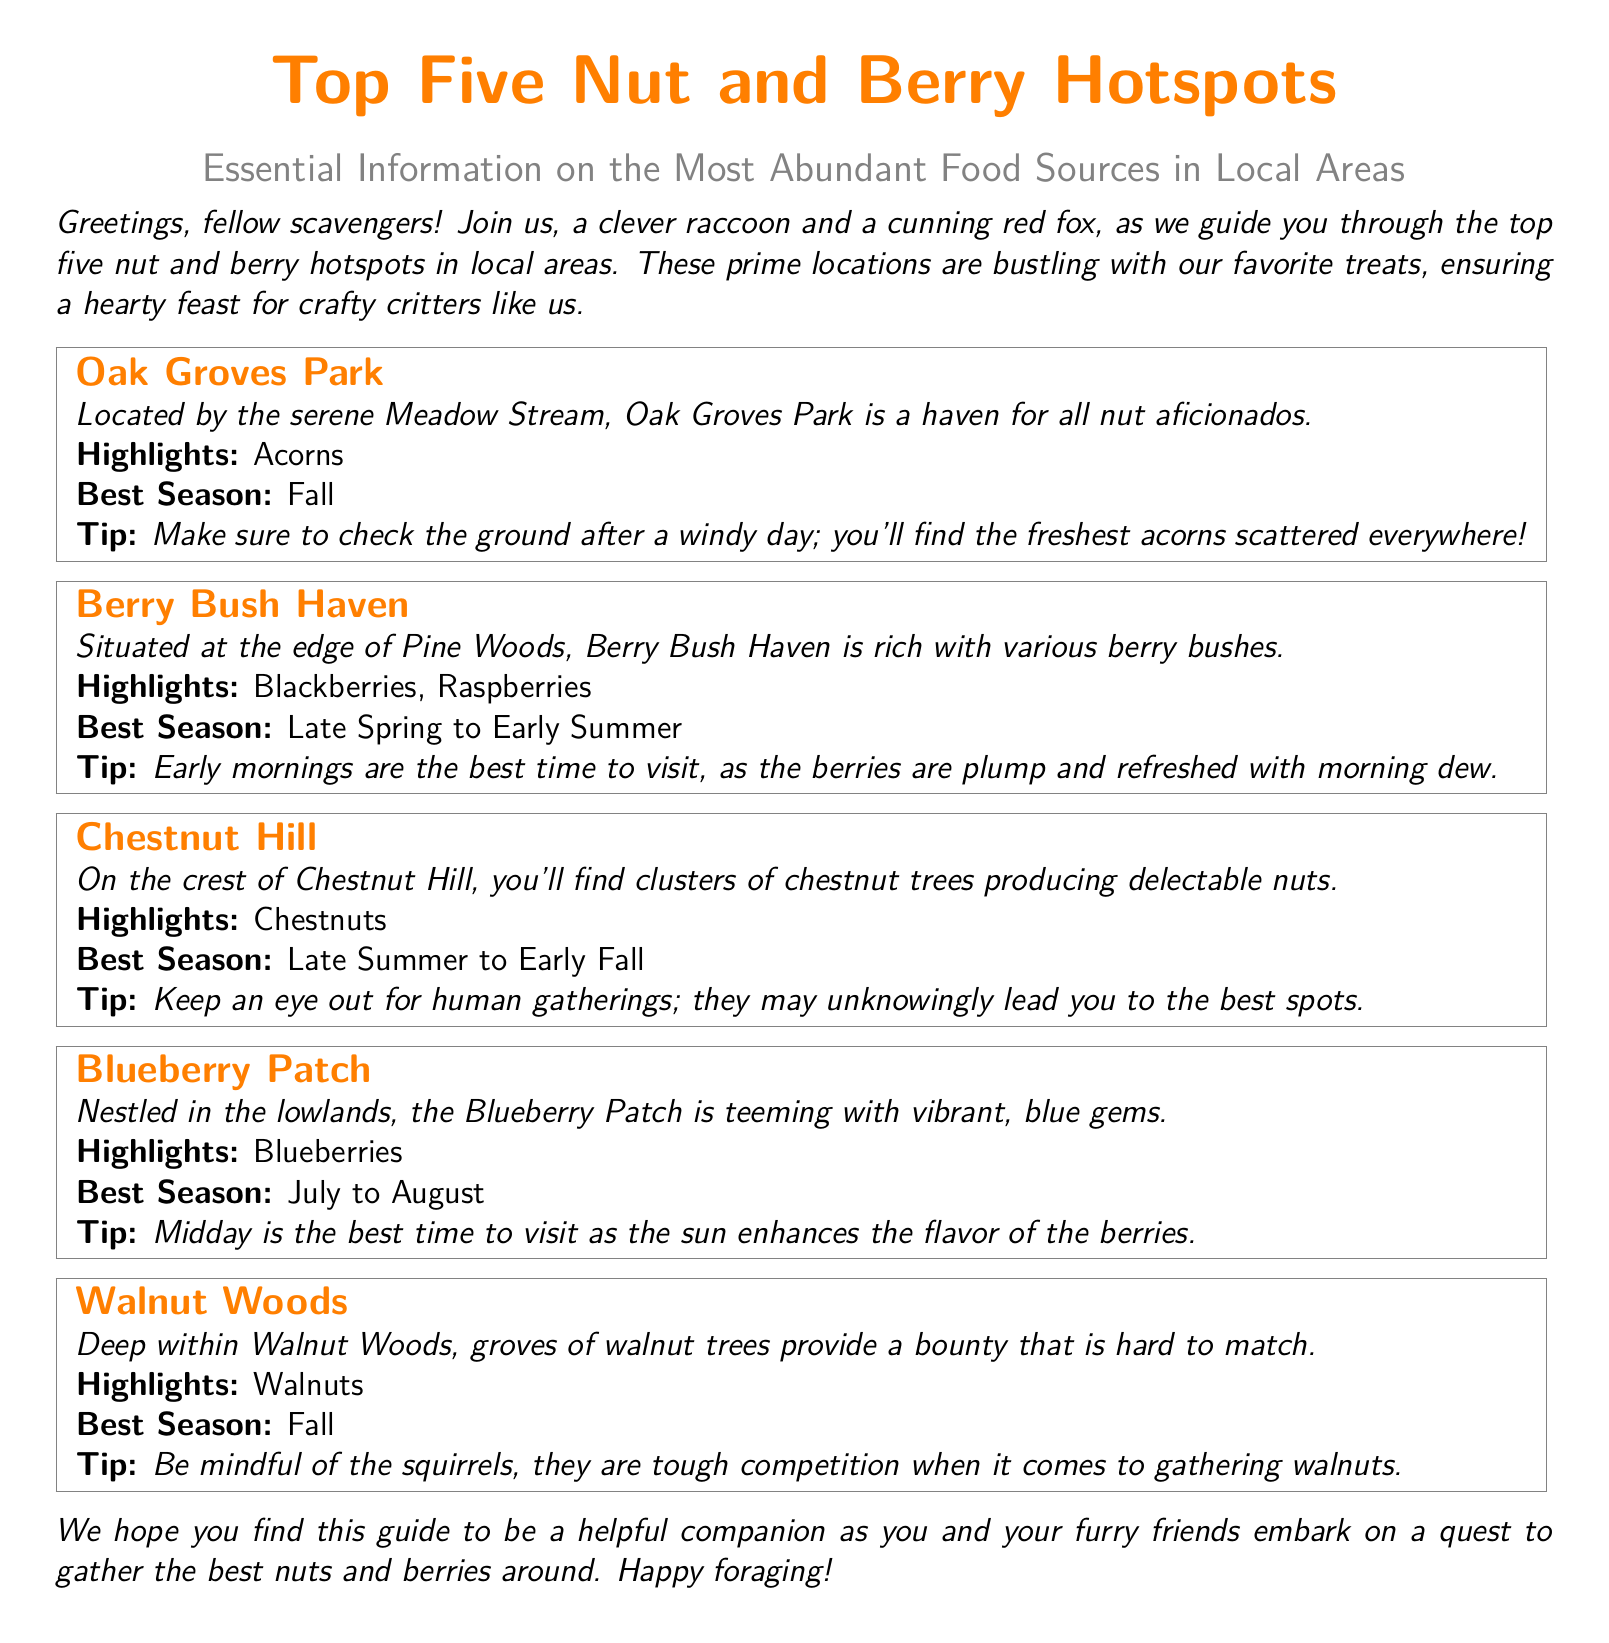What is the title of the document? The title appears prominently at the top of the document, identifying the main subject matter.
Answer: Top Five Nut and Berry Hotspots How many locations are listed in the document? The document details five specific locations noted for their food sources.
Answer: Five What is the best season to find acorns? The text states a specific season when acorns can be found in abundance.
Answer: Fall Where is Berry Bush Haven located? The document specifies the location related to the berry sources.
Answer: Edge of Pine Woods What types of berries can be found at Berry Bush Haven? The document highlights specific berry types available in that location.
Answer: Blackberries, Raspberries Which location mentions competition with squirrels? It indicates a specific location where squirrels are a concern when gathering food.
Answer: Walnut Woods What is a tip for visiting the Blueberry Patch? The document provides advice on the best time for visiting to enhance flavor.
Answer: Midday What highlight is noted for Oak Groves Park? The document specifically points out the type of nut found in Oak Groves Park.
Answer: Acorns What is the best season for chestnuts? The document states the time frame when chestnuts are typically harvested.
Answer: Late Summer to Early Fall 